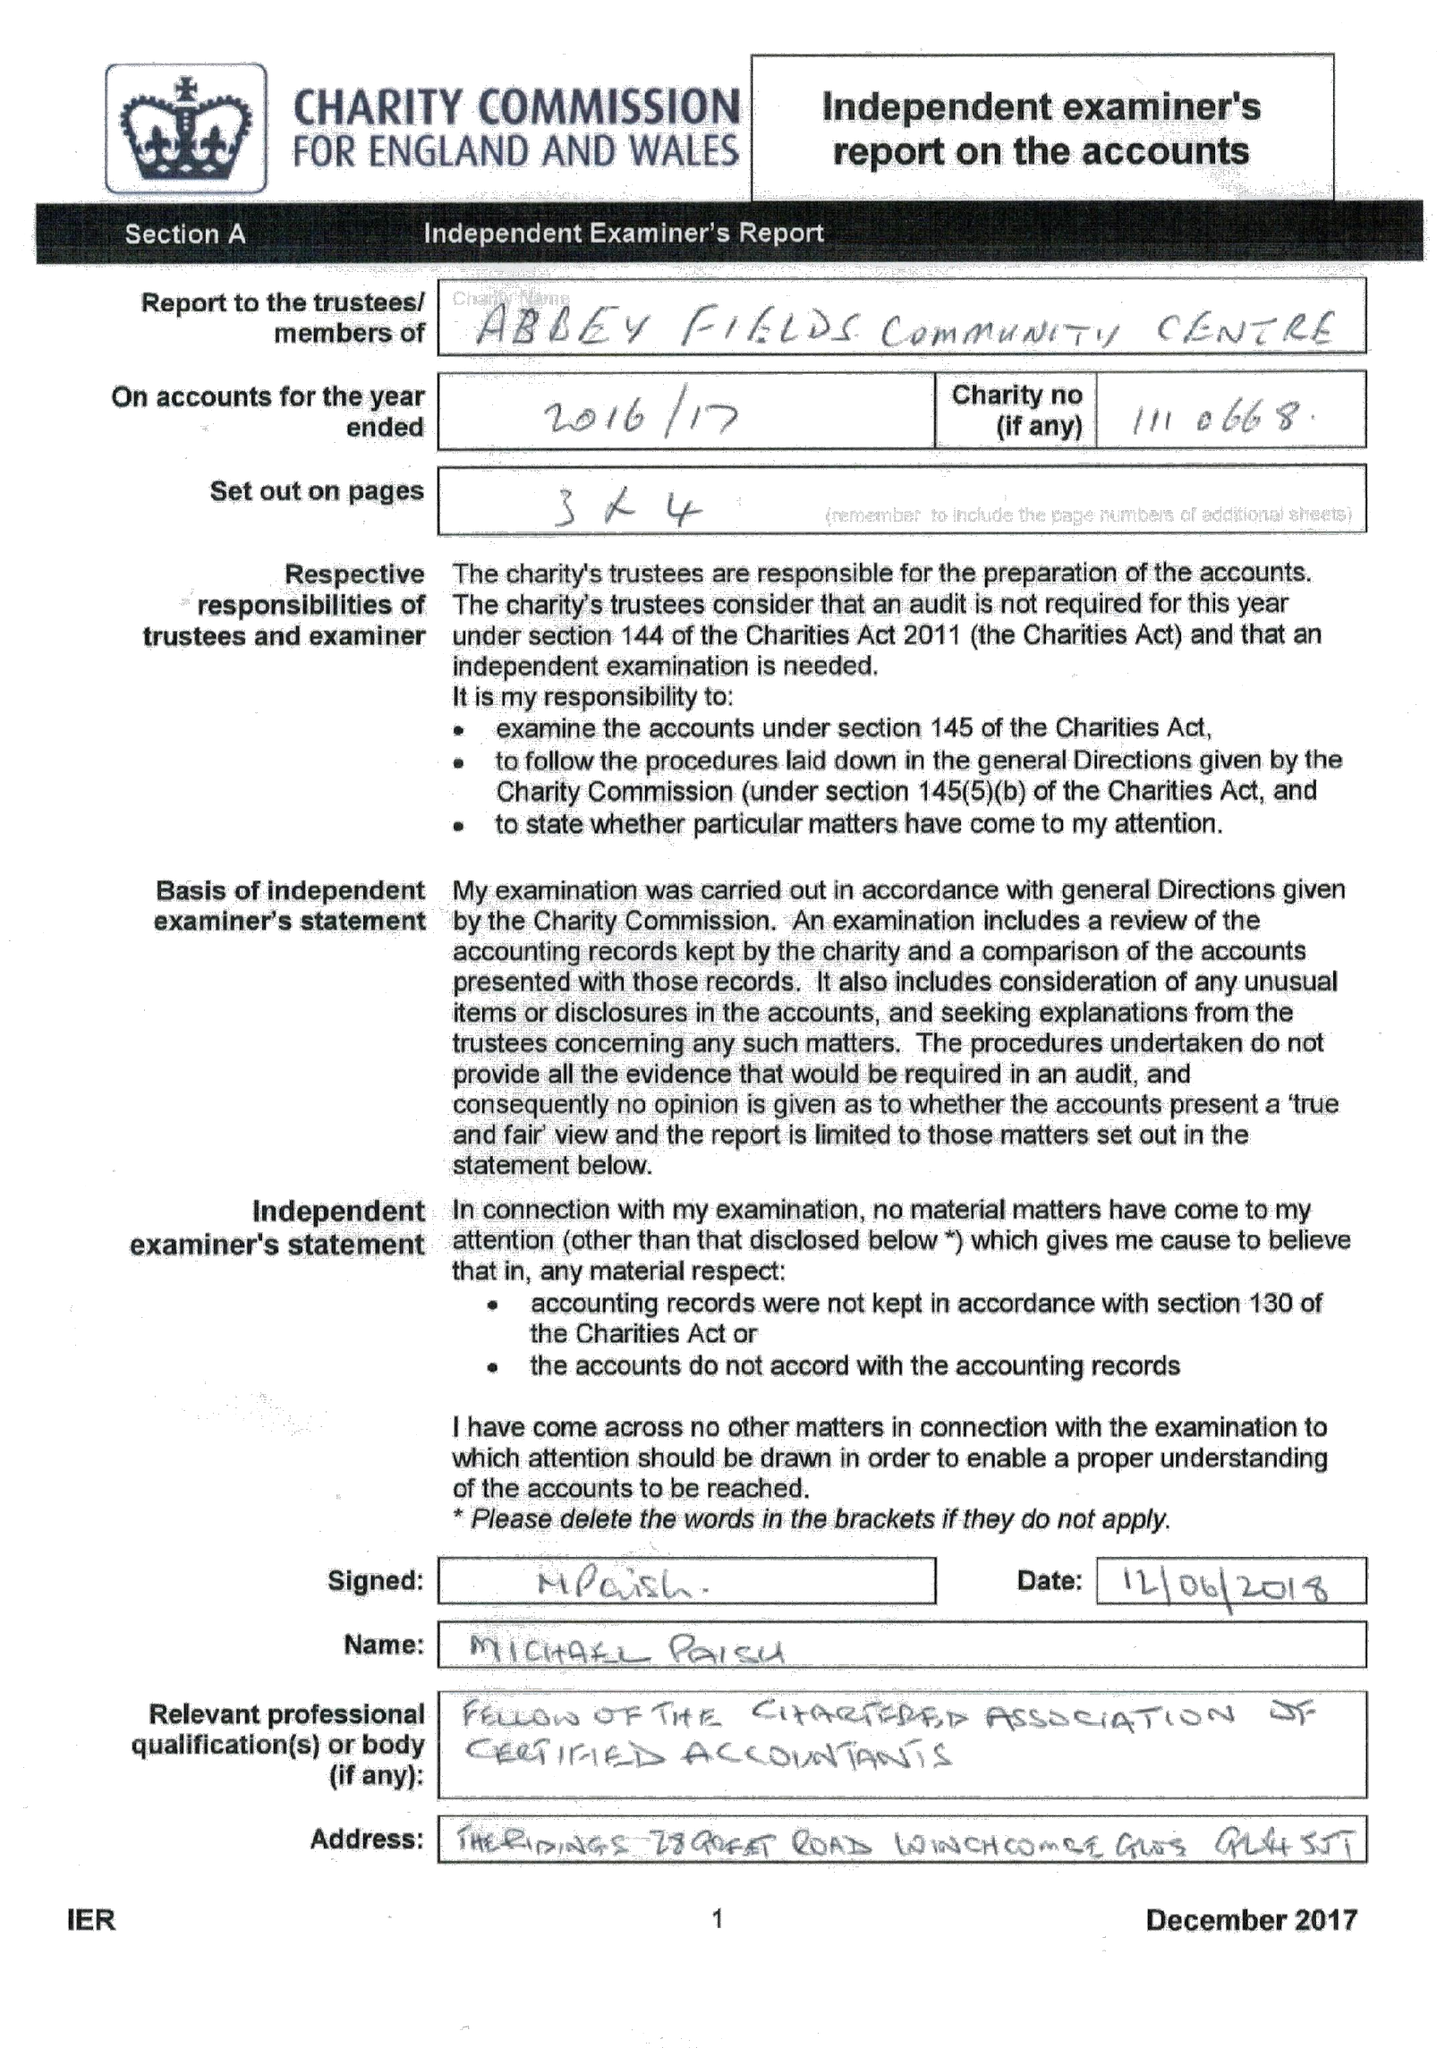What is the value for the income_annually_in_british_pounds?
Answer the question using a single word or phrase. 29611.00 